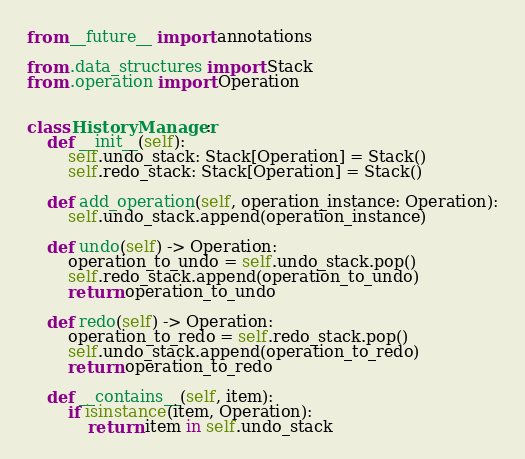<code> <loc_0><loc_0><loc_500><loc_500><_Python_>from __future__ import annotations

from .data_structures import Stack
from .operation import Operation


class HistoryManager:
    def __init__(self):
        self.undo_stack: Stack[Operation] = Stack()
        self.redo_stack: Stack[Operation] = Stack()

    def add_operation(self, operation_instance: Operation):
        self.undo_stack.append(operation_instance)

    def undo(self) -> Operation:
        operation_to_undo = self.undo_stack.pop()
        self.redo_stack.append(operation_to_undo)
        return operation_to_undo

    def redo(self) -> Operation:
        operation_to_redo = self.redo_stack.pop()
        self.undo_stack.append(operation_to_redo)
        return operation_to_redo

    def __contains__(self, item):
        if isinstance(item, Operation):
            return item in self.undo_stack
</code> 